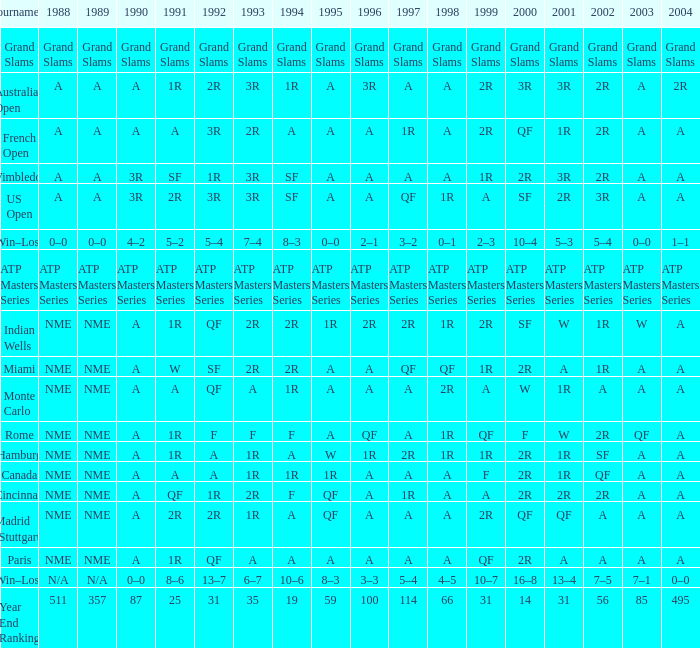What are the shows for 1988 when the shows for 1994 are 10-6? N/A. 